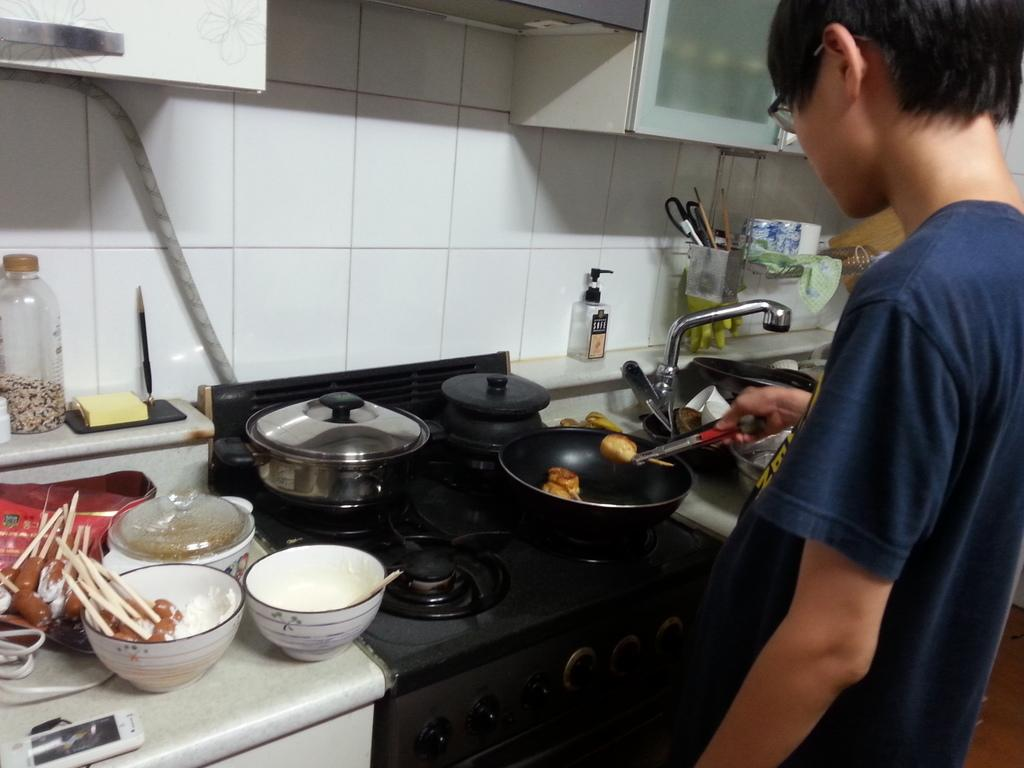What is the main subject of the image? The main subject of the image is a boy. What is the boy doing in the image? The boy is cooking food in the image. What can be seen on the kitchen platform? There are utensils on the kitchen platform in the image. What part of the room is visible in the image? The wall is visible in the image. What type of kite is the boy flying in the image? There is no kite present in the image; the boy is cooking food. How many eggs are on the kitchen platform in the image? There is no mention of eggs in the image; only utensils are mentioned on the kitchen platform. 